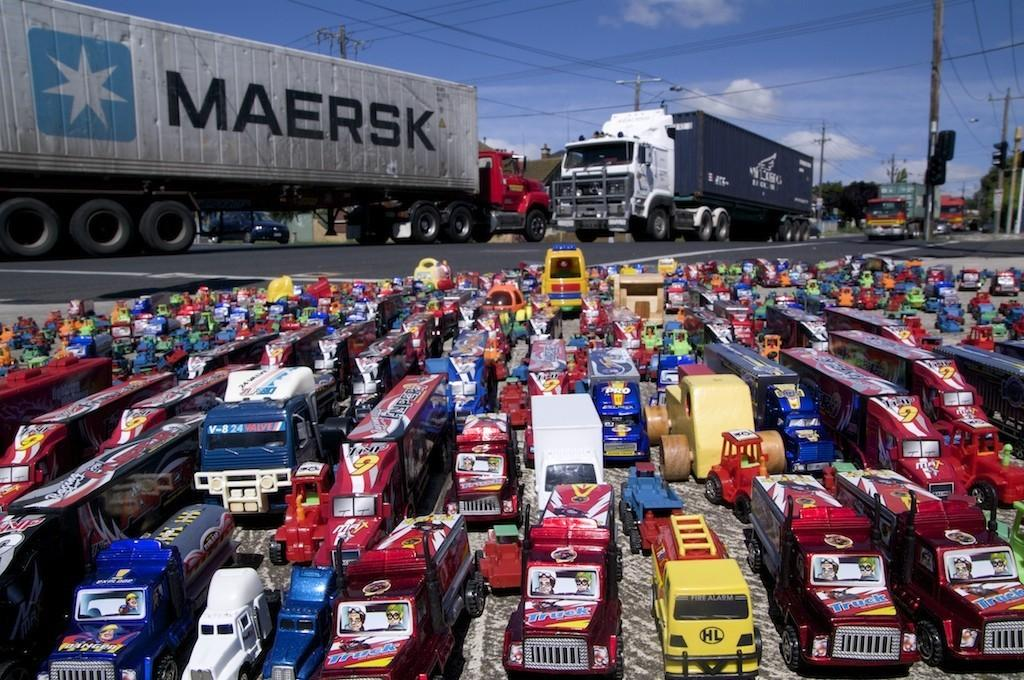What is happening on the road in the image? There are vehicles on the road in the image. What can be seen at the bottom of the image? There are toys at the bottom of the image. What is visible in the background of the image? There are poles, wires, and the sky visible in the background of the image. What type of feast is being prepared in the image? There is no feast being prepared in the image; it features vehicles on the road, toys at the bottom, and poles, wires, and the sky in the background. Can you tell me how many needles are visible in the image? There are no needles present in the image. 